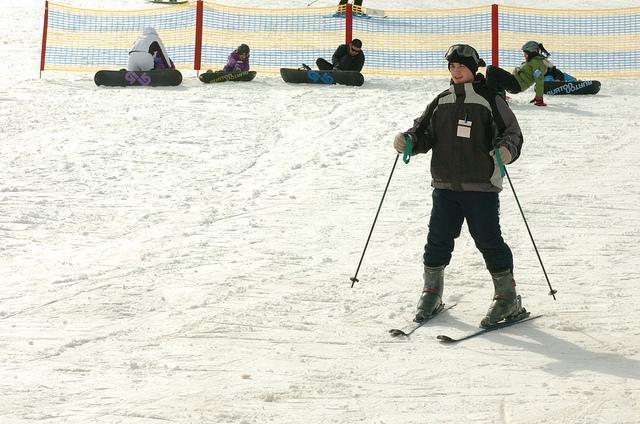How many people are seated?
Give a very brief answer. 4. How many bikes are below the outdoor wall decorations?
Give a very brief answer. 0. 